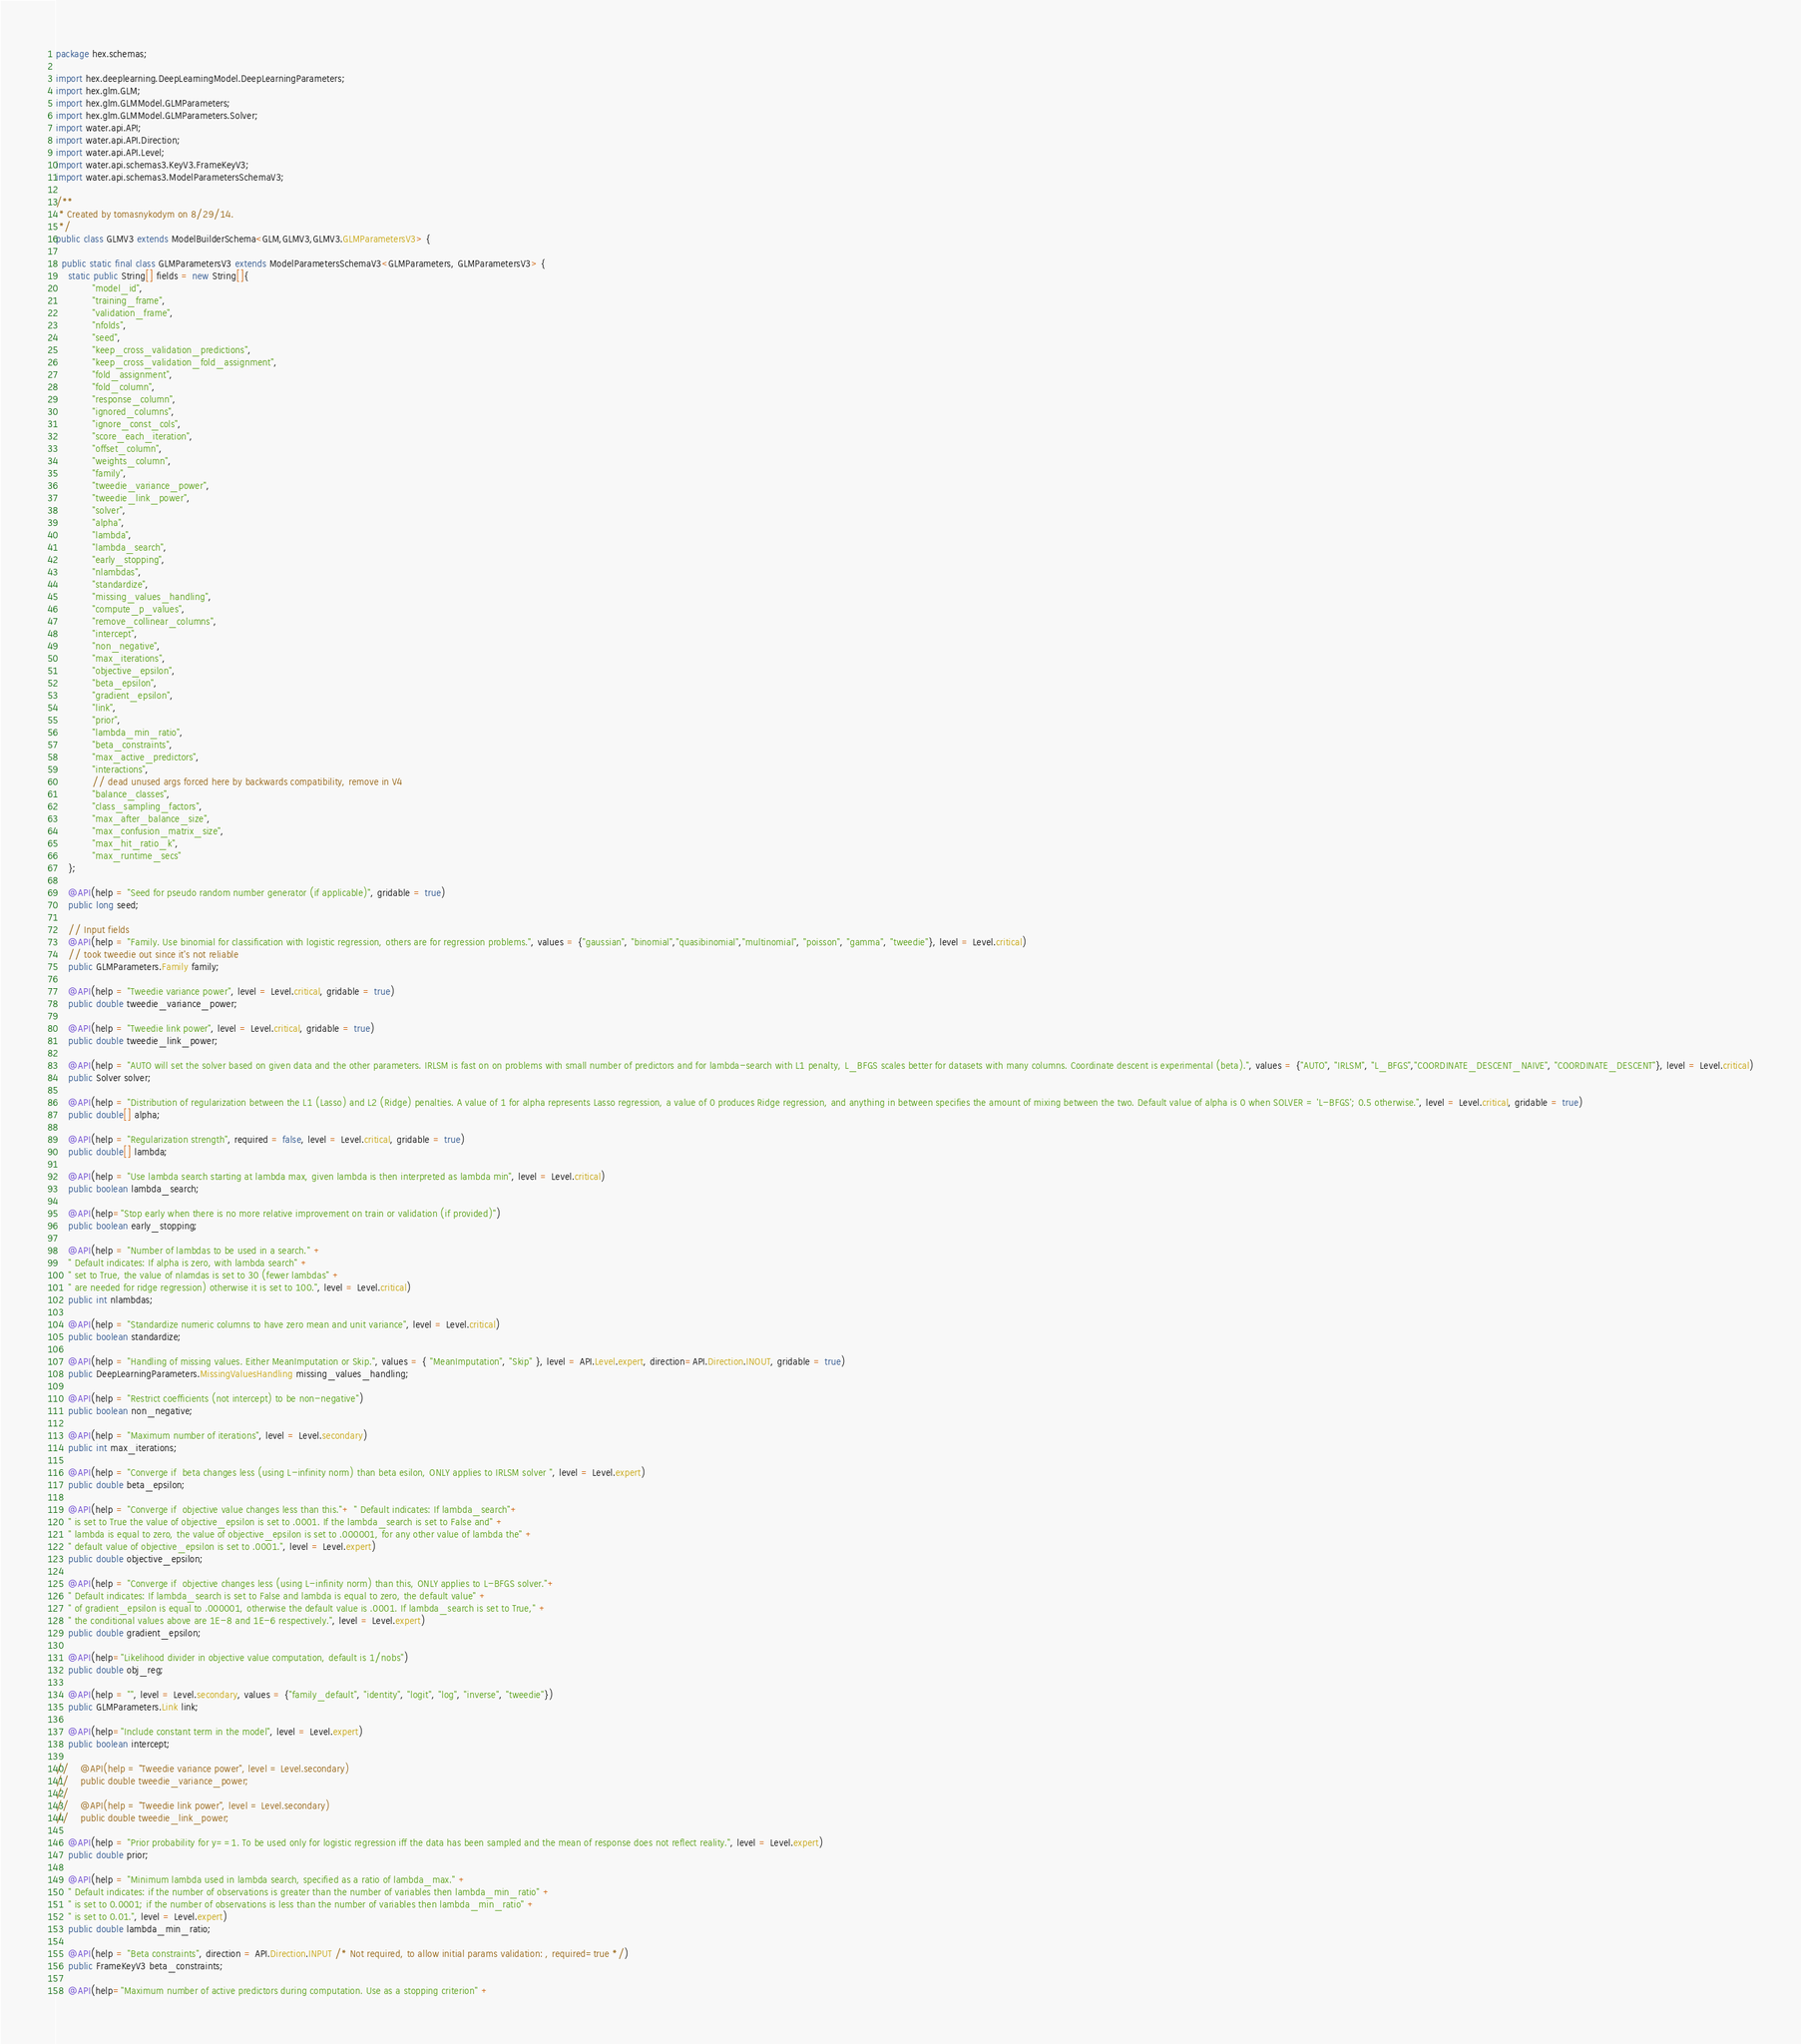Convert code to text. <code><loc_0><loc_0><loc_500><loc_500><_Java_>package hex.schemas;

import hex.deeplearning.DeepLearningModel.DeepLearningParameters;
import hex.glm.GLM;
import hex.glm.GLMModel.GLMParameters;
import hex.glm.GLMModel.GLMParameters.Solver;
import water.api.API;
import water.api.API.Direction;
import water.api.API.Level;
import water.api.schemas3.KeyV3.FrameKeyV3;
import water.api.schemas3.ModelParametersSchemaV3;

/**
 * Created by tomasnykodym on 8/29/14.
 */
public class GLMV3 extends ModelBuilderSchema<GLM,GLMV3,GLMV3.GLMParametersV3> {

  public static final class GLMParametersV3 extends ModelParametersSchemaV3<GLMParameters, GLMParametersV3> {
    static public String[] fields = new String[]{
            "model_id",
            "training_frame",
            "validation_frame",
            "nfolds",
            "seed",
            "keep_cross_validation_predictions",
            "keep_cross_validation_fold_assignment",
            "fold_assignment",
            "fold_column",
            "response_column",
            "ignored_columns",
            "ignore_const_cols",
            "score_each_iteration",
            "offset_column",
            "weights_column",
            "family",
            "tweedie_variance_power",
            "tweedie_link_power",
            "solver",
            "alpha",
            "lambda",
            "lambda_search",
            "early_stopping",
            "nlambdas",
            "standardize",
            "missing_values_handling",
            "compute_p_values",
            "remove_collinear_columns",
            "intercept",
            "non_negative",
            "max_iterations",
            "objective_epsilon",
            "beta_epsilon",
            "gradient_epsilon",
            "link",
            "prior",
            "lambda_min_ratio",
            "beta_constraints",
            "max_active_predictors",
            "interactions",
            // dead unused args forced here by backwards compatibility, remove in V4
            "balance_classes",
            "class_sampling_factors",
            "max_after_balance_size",
            "max_confusion_matrix_size",
            "max_hit_ratio_k",
            "max_runtime_secs"
    };

    @API(help = "Seed for pseudo random number generator (if applicable)", gridable = true)
    public long seed;

    // Input fields
    @API(help = "Family. Use binomial for classification with logistic regression, others are for regression problems.", values = {"gaussian", "binomial","quasibinomial","multinomial", "poisson", "gamma", "tweedie"}, level = Level.critical)
    // took tweedie out since it's not reliable
    public GLMParameters.Family family;

    @API(help = "Tweedie variance power", level = Level.critical, gridable = true)
    public double tweedie_variance_power;

    @API(help = "Tweedie link power", level = Level.critical, gridable = true)
    public double tweedie_link_power;

    @API(help = "AUTO will set the solver based on given data and the other parameters. IRLSM is fast on on problems with small number of predictors and for lambda-search with L1 penalty, L_BFGS scales better for datasets with many columns. Coordinate descent is experimental (beta).", values = {"AUTO", "IRLSM", "L_BFGS","COORDINATE_DESCENT_NAIVE", "COORDINATE_DESCENT"}, level = Level.critical)
    public Solver solver;

    @API(help = "Distribution of regularization between the L1 (Lasso) and L2 (Ridge) penalties. A value of 1 for alpha represents Lasso regression, a value of 0 produces Ridge regression, and anything in between specifies the amount of mixing between the two. Default value of alpha is 0 when SOLVER = 'L-BFGS'; 0.5 otherwise.", level = Level.critical, gridable = true)
    public double[] alpha;

    @API(help = "Regularization strength", required = false, level = Level.critical, gridable = true)
    public double[] lambda;

    @API(help = "Use lambda search starting at lambda max, given lambda is then interpreted as lambda min", level = Level.critical)
    public boolean lambda_search;

    @API(help="Stop early when there is no more relative improvement on train or validation (if provided)")
    public boolean early_stopping;

    @API(help = "Number of lambdas to be used in a search." +
    " Default indicates: If alpha is zero, with lambda search" +
    " set to True, the value of nlamdas is set to 30 (fewer lambdas" +
    " are needed for ridge regression) otherwise it is set to 100.", level = Level.critical)
    public int nlambdas;

    @API(help = "Standardize numeric columns to have zero mean and unit variance", level = Level.critical)
    public boolean standardize;

    @API(help = "Handling of missing values. Either MeanImputation or Skip.", values = { "MeanImputation", "Skip" }, level = API.Level.expert, direction=API.Direction.INOUT, gridable = true)
    public DeepLearningParameters.MissingValuesHandling missing_values_handling;

    @API(help = "Restrict coefficients (not intercept) to be non-negative")
    public boolean non_negative;

    @API(help = "Maximum number of iterations", level = Level.secondary)
    public int max_iterations;

    @API(help = "Converge if  beta changes less (using L-infinity norm) than beta esilon, ONLY applies to IRLSM solver ", level = Level.expert)
    public double beta_epsilon;

    @API(help = "Converge if  objective value changes less than this."+ " Default indicates: If lambda_search"+
    " is set to True the value of objective_epsilon is set to .0001. If the lambda_search is set to False and" +
    " lambda is equal to zero, the value of objective_epsilon is set to .000001, for any other value of lambda the" +
    " default value of objective_epsilon is set to .0001.", level = Level.expert)
    public double objective_epsilon;

    @API(help = "Converge if  objective changes less (using L-infinity norm) than this, ONLY applies to L-BFGS solver."+
    " Default indicates: If lambda_search is set to False and lambda is equal to zero, the default value" +
    " of gradient_epsilon is equal to .000001, otherwise the default value is .0001. If lambda_search is set to True," +
    " the conditional values above are 1E-8 and 1E-6 respectively.", level = Level.expert)
    public double gradient_epsilon;

    @API(help="Likelihood divider in objective value computation, default is 1/nobs")
    public double obj_reg;

    @API(help = "", level = Level.secondary, values = {"family_default", "identity", "logit", "log", "inverse", "tweedie"})
    public GLMParameters.Link link;

    @API(help="Include constant term in the model", level = Level.expert)
    public boolean intercept;

//    @API(help = "Tweedie variance power", level = Level.secondary)
//    public double tweedie_variance_power;
//
//    @API(help = "Tweedie link power", level = Level.secondary)
//    public double tweedie_link_power;

    @API(help = "Prior probability for y==1. To be used only for logistic regression iff the data has been sampled and the mean of response does not reflect reality.", level = Level.expert)
    public double prior;

    @API(help = "Minimum lambda used in lambda search, specified as a ratio of lambda_max." +
    " Default indicates: if the number of observations is greater than the number of variables then lambda_min_ratio" +
    " is set to 0.0001; if the number of observations is less than the number of variables then lambda_min_ratio" +
    " is set to 0.01.", level = Level.expert)
    public double lambda_min_ratio;

    @API(help = "Beta constraints", direction = API.Direction.INPUT /* Not required, to allow initial params validation: , required=true */)
    public FrameKeyV3 beta_constraints;

    @API(help="Maximum number of active predictors during computation. Use as a stopping criterion" +</code> 